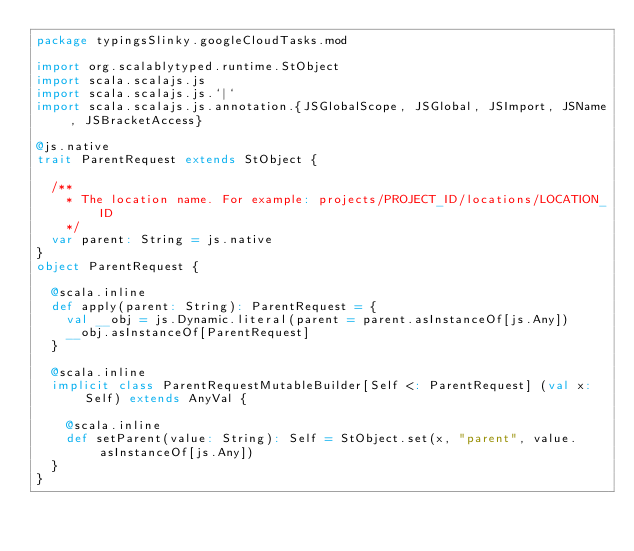<code> <loc_0><loc_0><loc_500><loc_500><_Scala_>package typingsSlinky.googleCloudTasks.mod

import org.scalablytyped.runtime.StObject
import scala.scalajs.js
import scala.scalajs.js.`|`
import scala.scalajs.js.annotation.{JSGlobalScope, JSGlobal, JSImport, JSName, JSBracketAccess}

@js.native
trait ParentRequest extends StObject {
  
  /**
    * The location name. For example: projects/PROJECT_ID/locations/LOCATION_ID
    */
  var parent: String = js.native
}
object ParentRequest {
  
  @scala.inline
  def apply(parent: String): ParentRequest = {
    val __obj = js.Dynamic.literal(parent = parent.asInstanceOf[js.Any])
    __obj.asInstanceOf[ParentRequest]
  }
  
  @scala.inline
  implicit class ParentRequestMutableBuilder[Self <: ParentRequest] (val x: Self) extends AnyVal {
    
    @scala.inline
    def setParent(value: String): Self = StObject.set(x, "parent", value.asInstanceOf[js.Any])
  }
}
</code> 